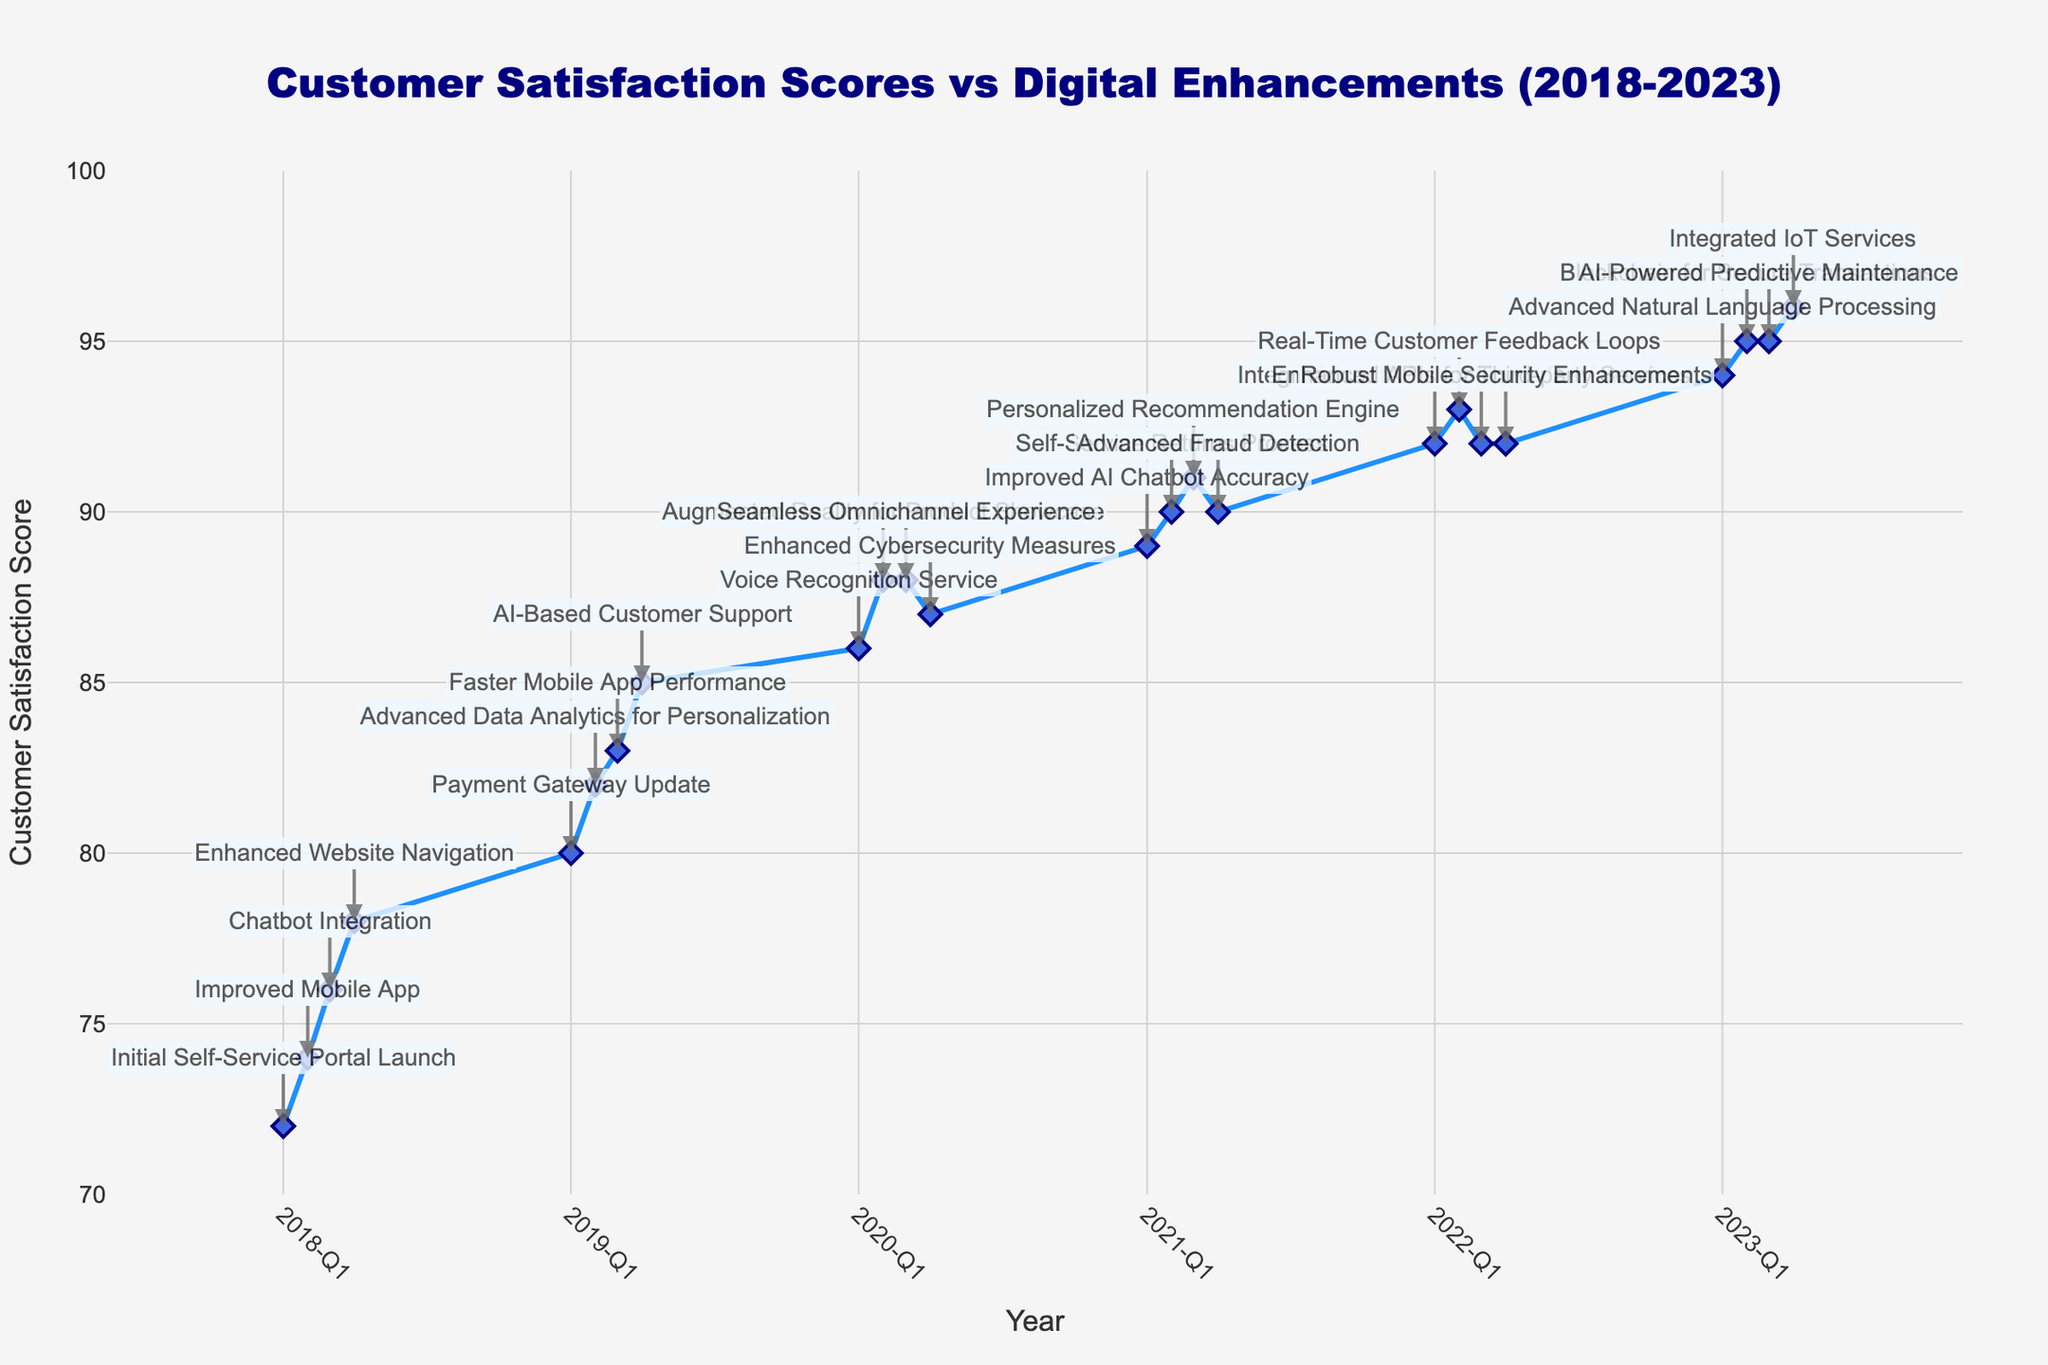What's the title of the figure? The title of the figure is prominently displayed at the top center. You can read it directly from the visual.
Answer: Customer Satisfaction Scores vs Digital Enhancements (2018-2023) How does the Customer Satisfaction Score in Q4 2023 compare to Q1 2018? Identify the scores for both quarters and compare them. Q1 2018 has a score of 72, while Q4 2023 has a score of 96. Since 96 is greater than 72, the score has increased.
Answer: Increased What is the general trend of Customer Satisfaction Scores over the five years? Observe the trajectory of the line plot from the start to the end. The line shows a general upward trend, indicating that the scores have been increasing over the years.
Answer: Increasing Which quarter has the highest Customer Satisfaction Score and what digital enhancement corresponds to it? Find the maximum score point on the plot, which is at Q4 2023 with a score of 96, and then check the corresponding digital enhancement from the annotation, which is "Integrated IoT Services".
Answer: Q4 2023, Integrated IoT Services What is the average Customer Satisfaction Score in 2021? Locate the four 2021 data points, which are 89, 90, 91, and 90. Calculate the average by summing them and dividing by the number of observations: (89 + 90 + 91 + 90) / 4 = 90.
Answer: 90 Between which two consecutive digital enhancements did the most significant increase in Customer Satisfaction Score occur? Evaluate the differences between each consecutive points. The largest increase is between Q4 2018 (78) and Q1 2019 (80) which corresponds to "Enhanced Website Navigation" and "Payment Gateway Update". The increase is 2 points.
Answer: Enhanced Website Navigation to Payment Gateway Update By how many points did the Customer Satisfaction Score increase from the launch of the initial self-service portal to the integration of IoT services? Identify the score at the launch of the initial self-service portal (72) and at the integration of IoT services (96). The difference is 96 - 72 = 24 points.
Answer: 24 points During which period did the Customer Satisfaction Score remain constant and what were the digital enhancements during that period? Find a flat segment in the plot. From Q2 2020 to Q3 2020, the score remains constant at 88. During this period, the enhancements are "Augmented Reality for Product Showcase" and "Seamless Omnichannel Experience".
Answer: Q2 2020 to Q3 2020, Augmented Reality for Product Showcase and Seamless Omnichannel Experience What was the effect of "Enhanced Cybersecurity Measures" on the Customer Satisfaction Score? Locate the enhancement (Q4 2020) and compare the scores before (Q3 2020 - 88) and after (Q4 2020 - 87). The score decreased by 1 point.
Answer: Decreased by 1 point 